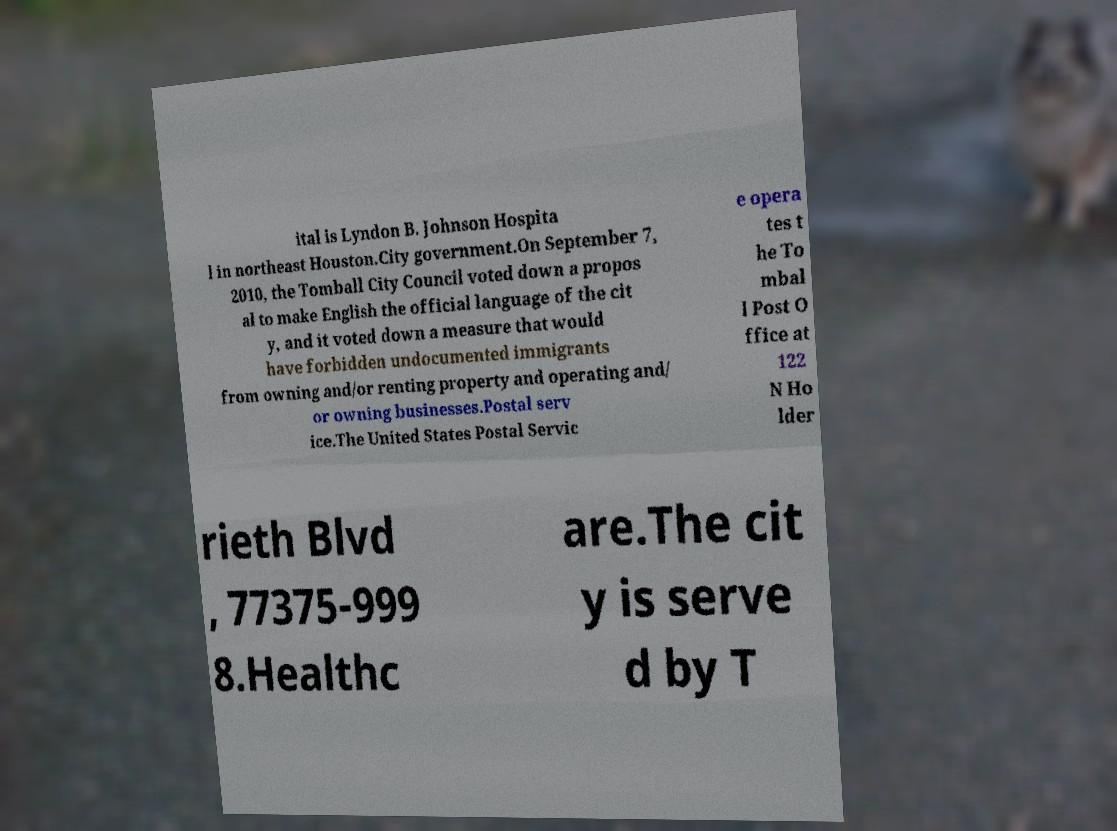What messages or text are displayed in this image? I need them in a readable, typed format. ital is Lyndon B. Johnson Hospita l in northeast Houston.City government.On September 7, 2010, the Tomball City Council voted down a propos al to make English the official language of the cit y, and it voted down a measure that would have forbidden undocumented immigrants from owning and/or renting property and operating and/ or owning businesses.Postal serv ice.The United States Postal Servic e opera tes t he To mbal l Post O ffice at 122 N Ho lder rieth Blvd , 77375-999 8.Healthc are.The cit y is serve d by T 